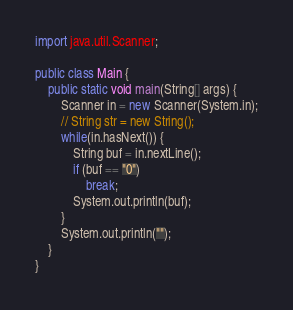Convert code to text. <code><loc_0><loc_0><loc_500><loc_500><_Java_>import java.util.Scanner;

public class Main {
    public static void main(String[] args) {
        Scanner in = new Scanner(System.in);
        // String str = new String();
        while(in.hasNext()) {
            String buf = in.nextLine();
            if (buf == "0")
            	break;
            System.out.println(buf);
        }
        System.out.println("");
    }
}</code> 